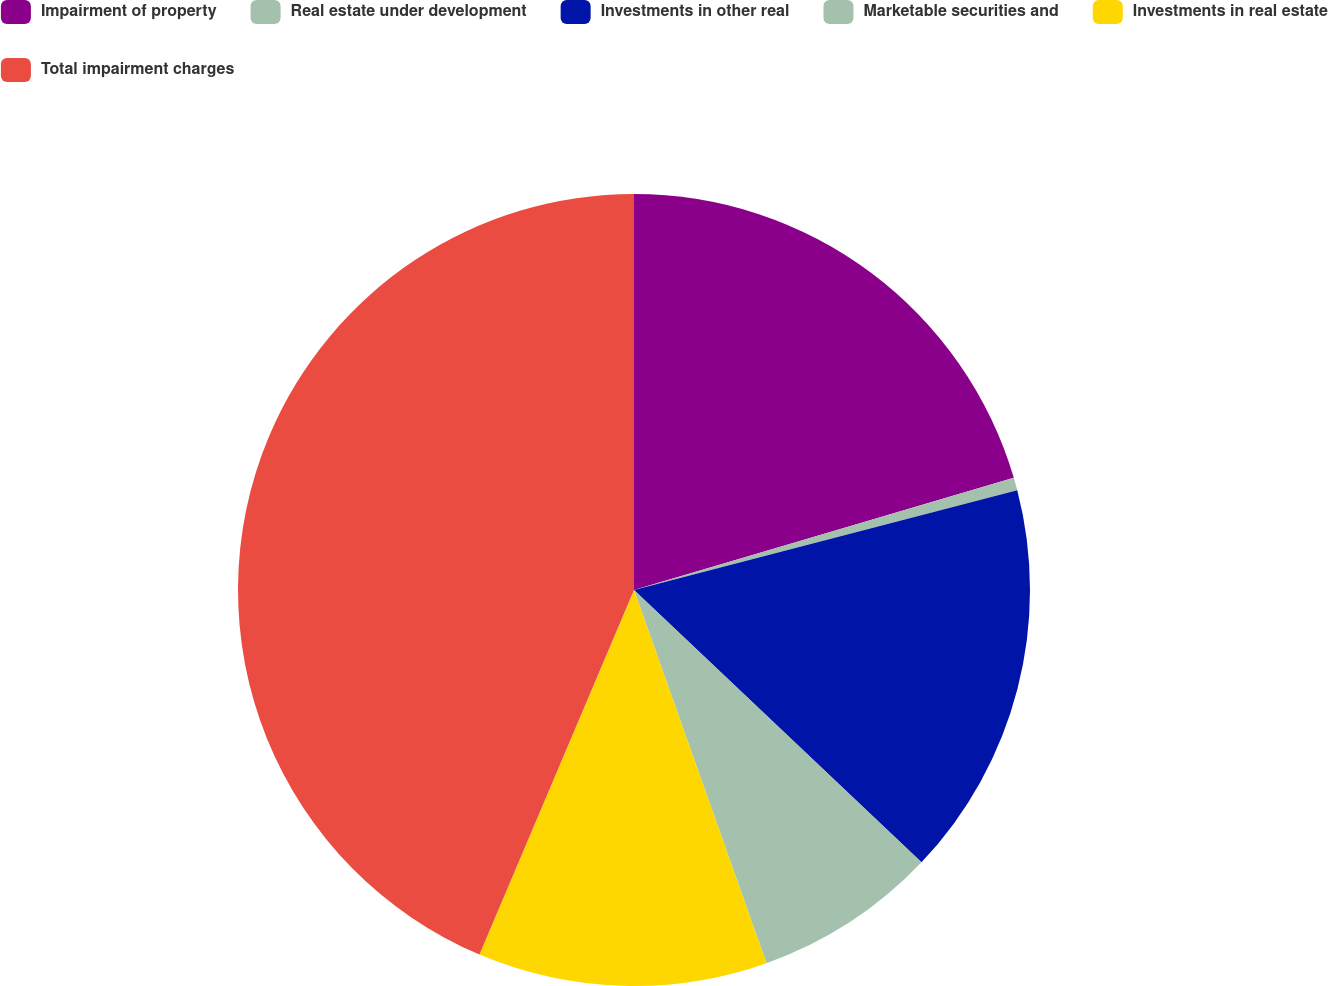Convert chart to OTSL. <chart><loc_0><loc_0><loc_500><loc_500><pie_chart><fcel>Impairment of property<fcel>Real estate under development<fcel>Investments in other real<fcel>Marketable securities and<fcel>Investments in real estate<fcel>Total impairment charges<nl><fcel>20.43%<fcel>0.52%<fcel>16.12%<fcel>7.5%<fcel>11.81%<fcel>43.62%<nl></chart> 